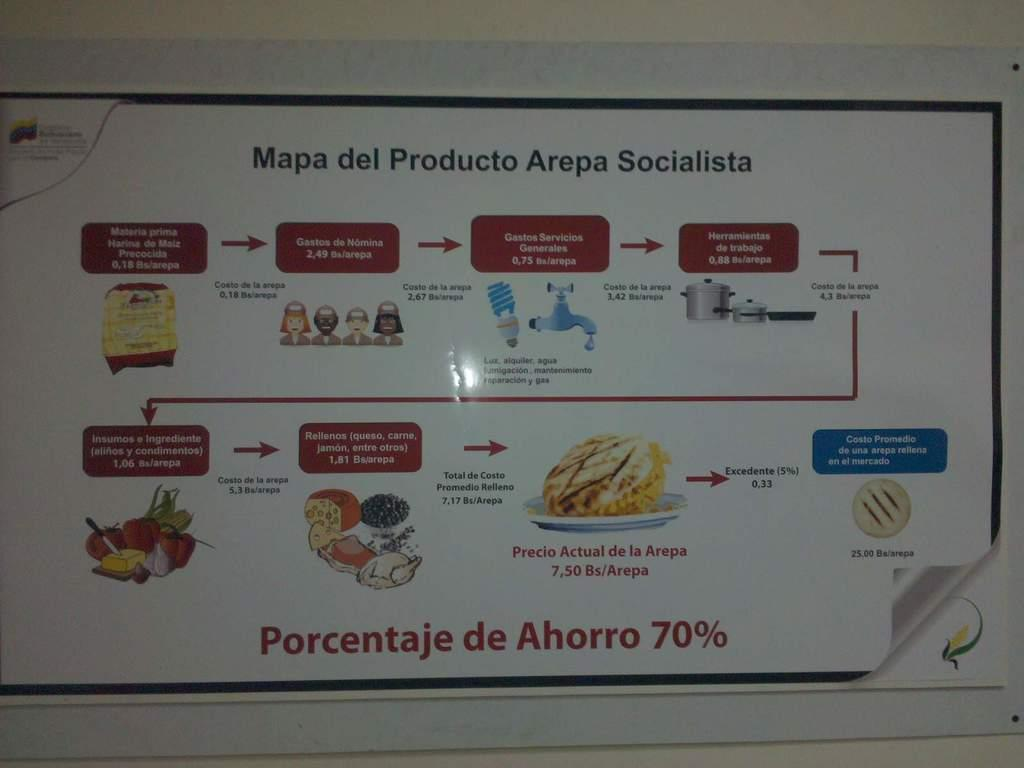What is the main subject of the image? The main subject of the image is a chart. What is the name of the chart? The chart has the name "Mapa del arepa socialista." Where is the chart located in the image? The chart is pasted on a wall. What type of stitch is used to attach the chart to the wall? There is no mention of a stitch or any specific method of attaching the chart to the wall in the image. 